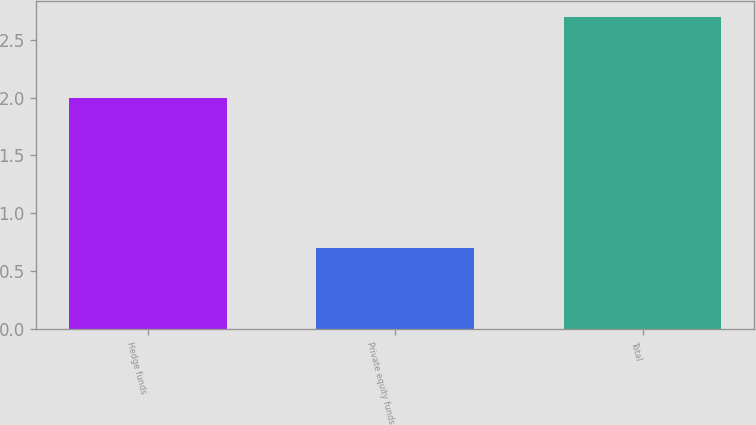Convert chart. <chart><loc_0><loc_0><loc_500><loc_500><bar_chart><fcel>Hedge funds<fcel>Private equity funds<fcel>Total<nl><fcel>2<fcel>0.7<fcel>2.7<nl></chart> 